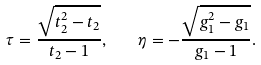Convert formula to latex. <formula><loc_0><loc_0><loc_500><loc_500>\tau = \frac { \sqrt { t _ { 2 } ^ { 2 } - t _ { 2 } } } { t _ { 2 } - 1 } , \quad \eta = - \frac { \sqrt { g _ { 1 } ^ { 2 } - g _ { 1 } } } { g _ { 1 } - 1 } .</formula> 